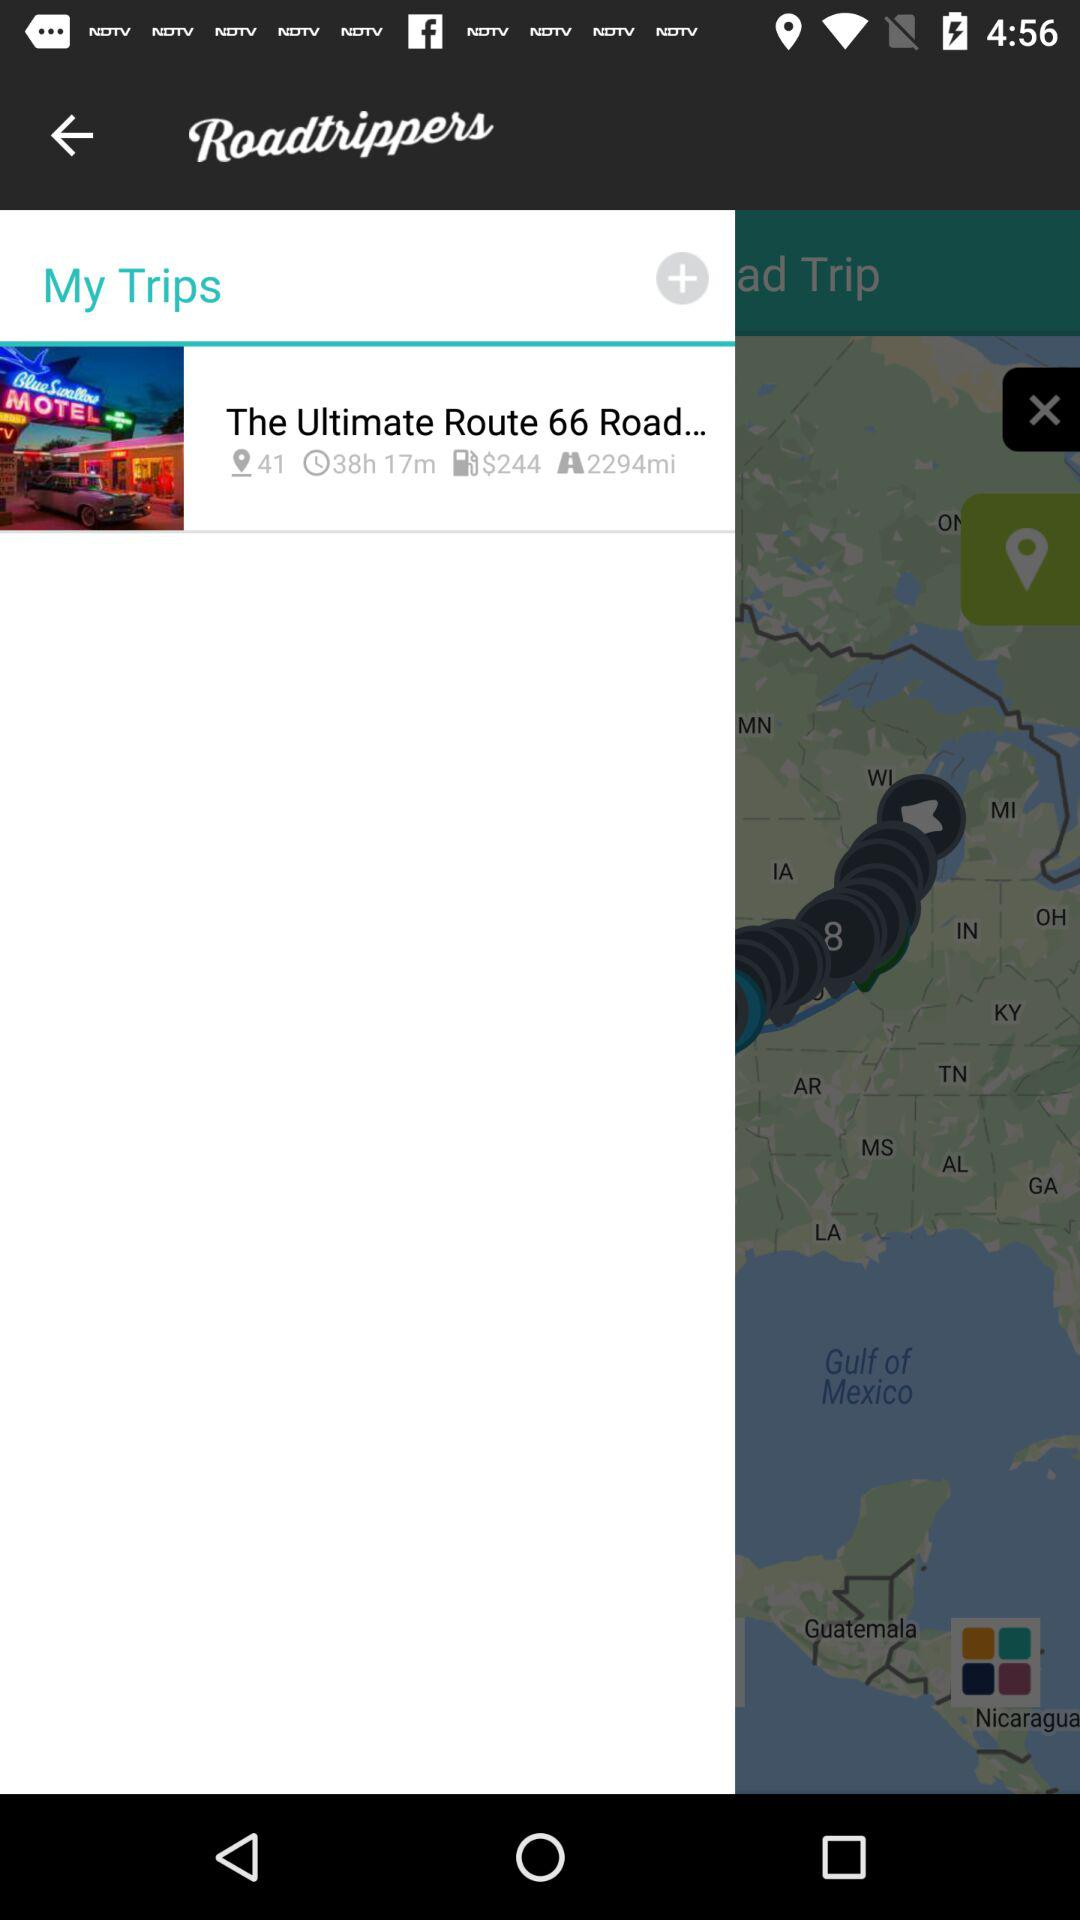What is the cost of the fuel on "The Ultimate Route 66 Road..."? The cost of the fuel is $244. 